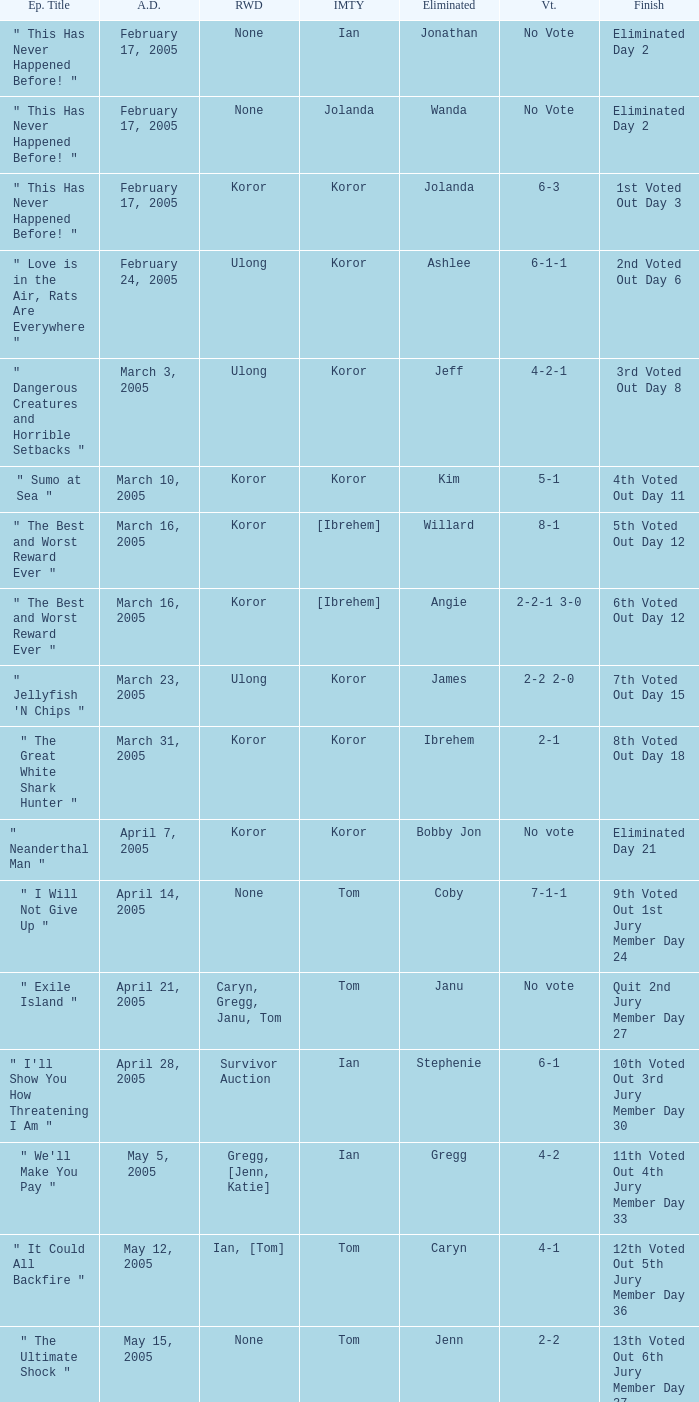Who received the reward on the episode where the finish was "3rd voted out day 8"? Ulong. 